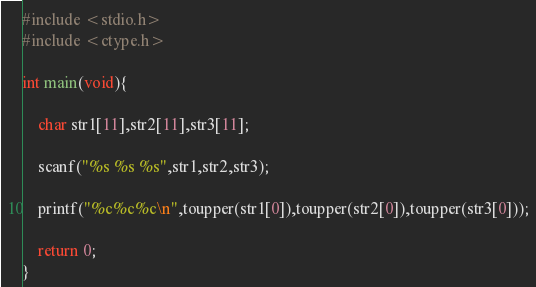Convert code to text. <code><loc_0><loc_0><loc_500><loc_500><_C_>#include <stdio.h>
#include <ctype.h>

int main(void){

	char str1[11],str2[11],str3[11];

	scanf("%s %s %s",str1,str2,str3);

	printf("%c%c%c\n",toupper(str1[0]),toupper(str2[0]),toupper(str3[0]));

	return 0;
}</code> 